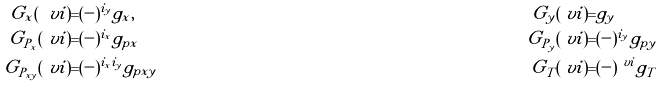<formula> <loc_0><loc_0><loc_500><loc_500>G _ { x } ( \ v i ) = & ( - ) ^ { i _ { y } } g _ { x } , & G _ { y } ( \ v i ) = & g _ { y } \\ G _ { P _ { x } } ( \ v i ) = & ( - ) ^ { i _ { x } } g _ { p x } & G _ { P _ { y } } ( \ v i ) = & ( - ) ^ { i _ { y } } g _ { p y } \\ G _ { P _ { x y } } ( \ v i ) = & ( - ) ^ { i _ { x } i _ { y } } g _ { p x y } & G _ { T } ( \ v i ) = & ( - ) ^ { \ v i } g _ { T }</formula> 